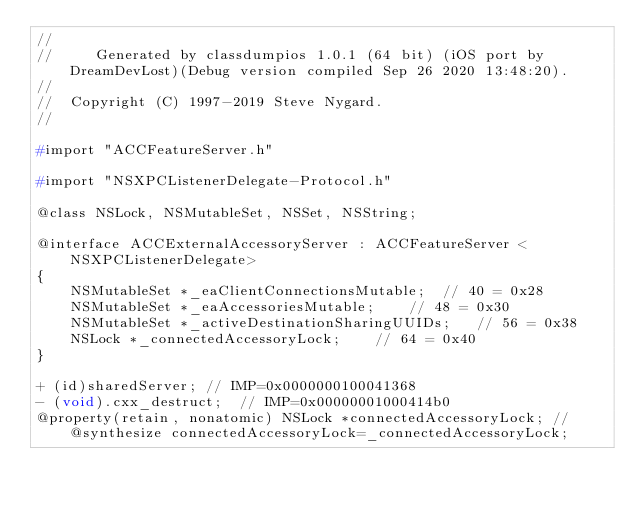Convert code to text. <code><loc_0><loc_0><loc_500><loc_500><_C_>//
//     Generated by classdumpios 1.0.1 (64 bit) (iOS port by DreamDevLost)(Debug version compiled Sep 26 2020 13:48:20).
//
//  Copyright (C) 1997-2019 Steve Nygard.
//

#import "ACCFeatureServer.h"

#import "NSXPCListenerDelegate-Protocol.h"

@class NSLock, NSMutableSet, NSSet, NSString;

@interface ACCExternalAccessoryServer : ACCFeatureServer <NSXPCListenerDelegate>
{
    NSMutableSet *_eaClientConnectionsMutable;	// 40 = 0x28
    NSMutableSet *_eaAccessoriesMutable;	// 48 = 0x30
    NSMutableSet *_activeDestinationSharingUUIDs;	// 56 = 0x38
    NSLock *_connectedAccessoryLock;	// 64 = 0x40
}

+ (id)sharedServer;	// IMP=0x0000000100041368
- (void).cxx_destruct;	// IMP=0x00000001000414b0
@property(retain, nonatomic) NSLock *connectedAccessoryLock; // @synthesize connectedAccessoryLock=_connectedAccessoryLock;</code> 